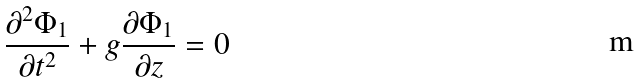Convert formula to latex. <formula><loc_0><loc_0><loc_500><loc_500>\frac { \partial ^ { 2 } \Phi _ { 1 } } { \partial t ^ { 2 } } + g \frac { \partial \Phi _ { 1 } } { \partial z } = 0</formula> 